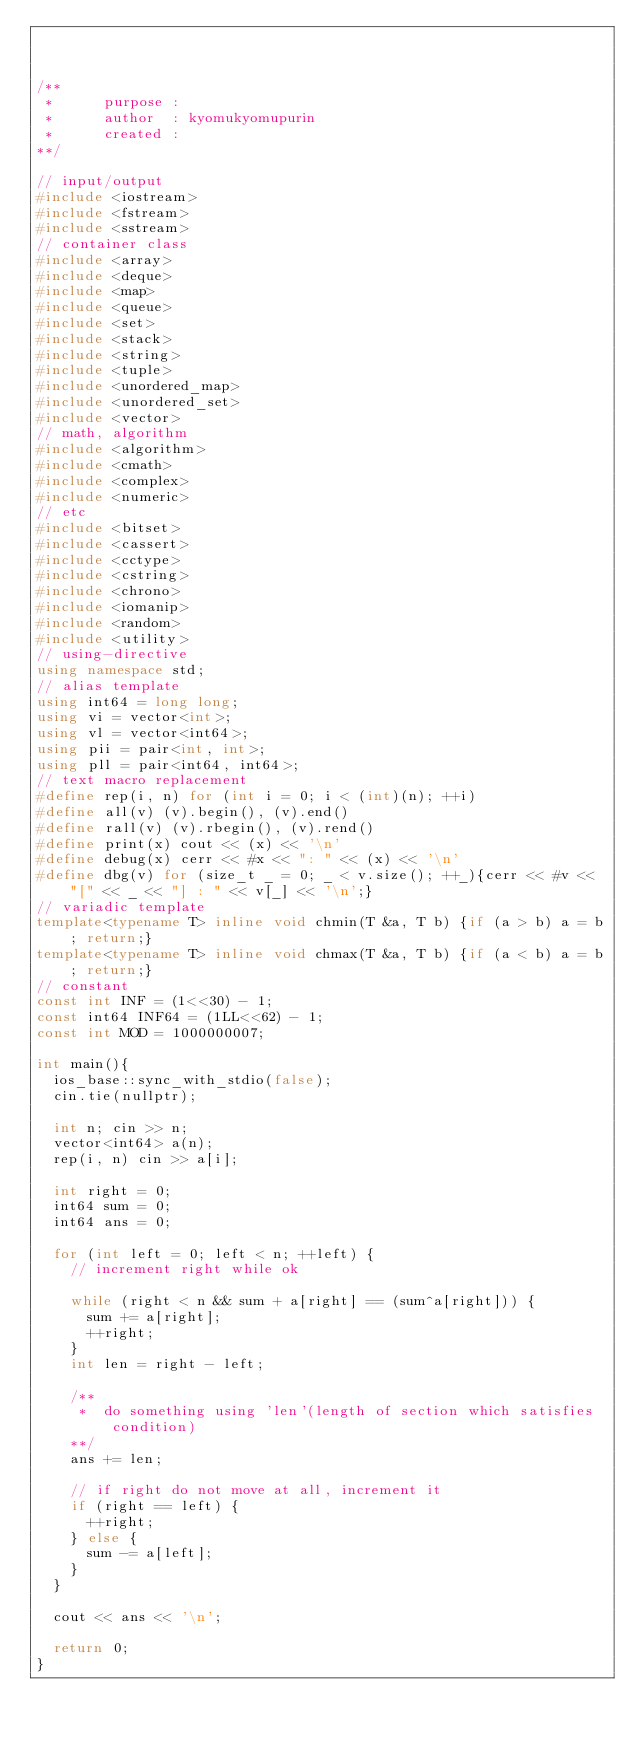<code> <loc_0><loc_0><loc_500><loc_500><_C++_>


/**
 *      purpose : 
 *      author  : kyomukyomupurin
 *      created : 
**/

// input/output
#include <iostream>
#include <fstream>
#include <sstream>
// container class
#include <array>
#include <deque>
#include <map>
#include <queue>
#include <set>
#include <stack>
#include <string>
#include <tuple>
#include <unordered_map>
#include <unordered_set>
#include <vector>
// math, algorithm
#include <algorithm>
#include <cmath>
#include <complex>
#include <numeric>
// etc
#include <bitset>
#include <cassert>
#include <cctype>
#include <cstring>
#include <chrono>
#include <iomanip>
#include <random>
#include <utility>
// using-directive
using namespace std;
// alias template
using int64 = long long;
using vi = vector<int>;
using vl = vector<int64>;
using pii = pair<int, int>;
using pll = pair<int64, int64>;
// text macro replacement
#define rep(i, n) for (int i = 0; i < (int)(n); ++i)
#define all(v) (v).begin(), (v).end()
#define rall(v) (v).rbegin(), (v).rend()
#define print(x) cout << (x) << '\n'
#define debug(x) cerr << #x << ": " << (x) << '\n'
#define dbg(v) for (size_t _ = 0; _ < v.size(); ++_){cerr << #v << "[" << _ << "] : " << v[_] << '\n';}
// variadic template
template<typename T> inline void chmin(T &a, T b) {if (a > b) a = b; return;}
template<typename T> inline void chmax(T &a, T b) {if (a < b) a = b; return;}
// constant
const int INF = (1<<30) - 1;
const int64 INF64 = (1LL<<62) - 1;
const int MOD = 1000000007;

int main(){
  ios_base::sync_with_stdio(false);
  cin.tie(nullptr);
  
  int n; cin >> n;
  vector<int64> a(n);
  rep(i, n) cin >> a[i];

  int right = 0;
  int64 sum = 0;
  int64 ans = 0;

  for (int left = 0; left < n; ++left) {
    // increment right while ok

    while (right < n && sum + a[right] == (sum^a[right])) {
      sum += a[right];
      ++right;
    }
    int len = right - left;

    /**
     *  do something using 'len'(length of section which satisfies condition)
    **/
    ans += len;

    // if right do not move at all, increment it
    if (right == left) {
      ++right;
    } else {
      sum -= a[left];
    }
  }

  cout << ans << '\n';

  return 0;
}</code> 